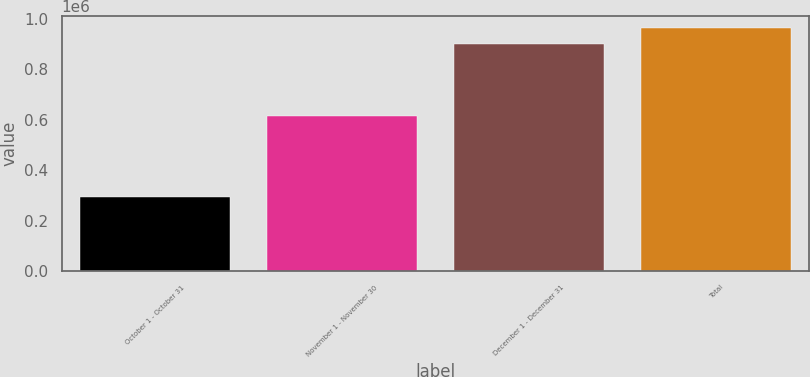<chart> <loc_0><loc_0><loc_500><loc_500><bar_chart><fcel>October 1 - October 31<fcel>November 1 - November 30<fcel>December 1 - December 31<fcel>Total<nl><fcel>292255<fcel>614311<fcel>902920<fcel>963986<nl></chart> 